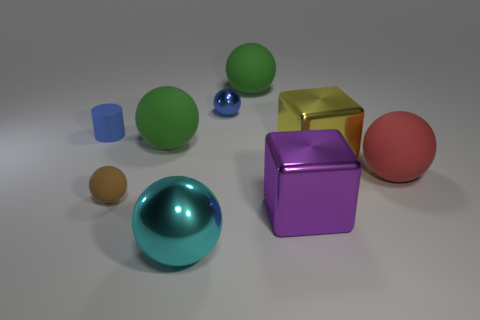Is the cylinder made of the same material as the large red sphere?
Offer a terse response. Yes. The red object that is the same shape as the cyan shiny thing is what size?
Make the answer very short. Large. What is the big thing that is left of the large red sphere and to the right of the big purple object made of?
Provide a succinct answer. Metal. Are there an equal number of tiny brown objects that are behind the purple block and yellow shiny cubes?
Provide a short and direct response. Yes. How many things are small objects that are to the right of the cylinder or small brown balls?
Your response must be concise. 2. There is a shiny ball right of the cyan ball; does it have the same color as the cylinder?
Your response must be concise. Yes. What is the size of the metal ball behind the large metallic sphere?
Offer a very short reply. Small. There is a thing that is to the right of the cube that is behind the small brown rubber object; what shape is it?
Offer a terse response. Sphere. What color is the other big metallic thing that is the same shape as the yellow shiny thing?
Offer a terse response. Purple. Do the shiny block in front of the yellow shiny cube and the rubber cylinder have the same size?
Give a very brief answer. No. 